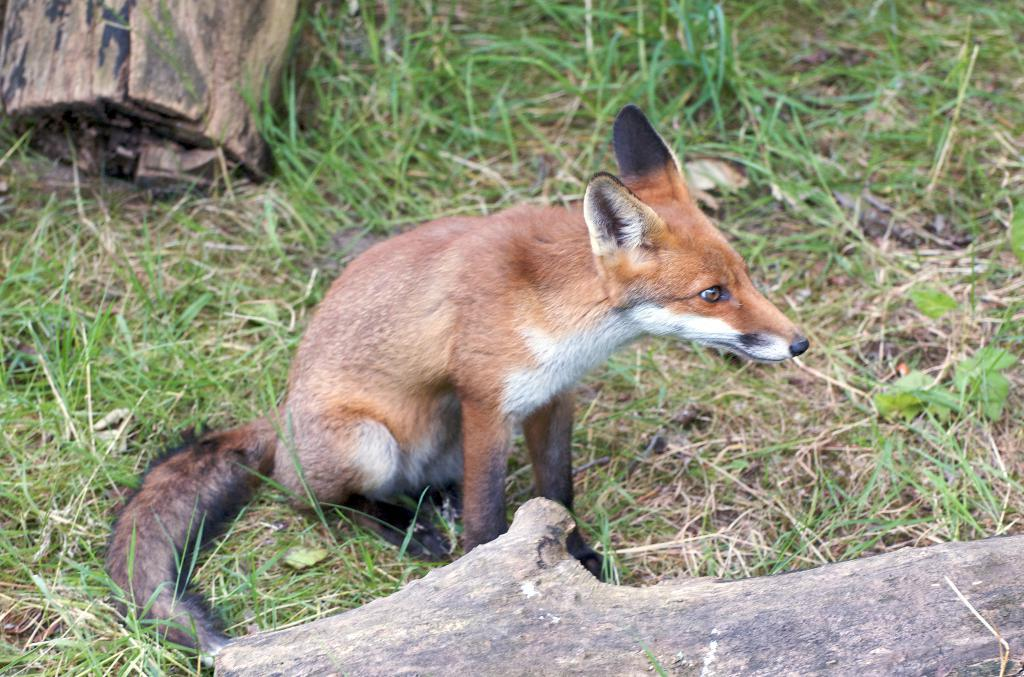What type of animal is in the image? The type of animal cannot be determined from the provided facts. What is on the ground in the image? There are wooden logs on the ground in the image. What can be seen in the background of the image? There is grass visible in the background of the image. What type of polish is being applied to the coast in the image? There is no mention of polish or a coast in the provided facts, so this question cannot be answered. 